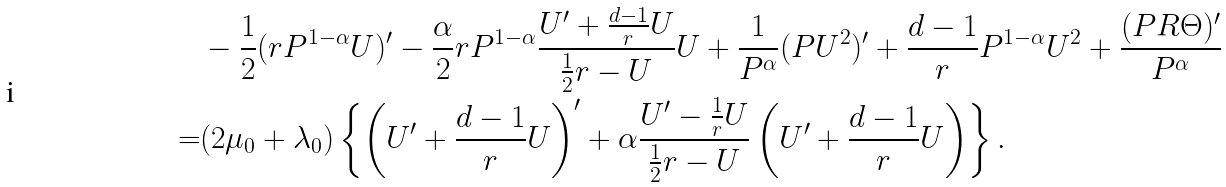Convert formula to latex. <formula><loc_0><loc_0><loc_500><loc_500>& - \frac { 1 } { 2 } ( r P ^ { 1 - \alpha } U ) ^ { \prime } - \frac { \alpha } { 2 } r P ^ { 1 - \alpha } \frac { U ^ { \prime } + \frac { d - 1 } { r } U } { \frac { 1 } { 2 } r - U } U + \frac { 1 } { P ^ { \alpha } } ( P U ^ { 2 } ) ^ { \prime } + \frac { d - 1 } { r } P ^ { 1 - \alpha } U ^ { 2 } + \frac { ( P R \Theta ) ^ { \prime } } { P ^ { \alpha } } \\ = & ( 2 \mu _ { 0 } + \lambda _ { 0 } ) \left \{ \left ( U ^ { \prime } + \frac { d - 1 } { r } U \right ) ^ { \prime } + \alpha \frac { U ^ { \prime } - \frac { 1 } { r } U } { \frac { 1 } { 2 } r - U } \left ( U ^ { \prime } + \frac { d - 1 } { r } U \right ) \right \} .</formula> 